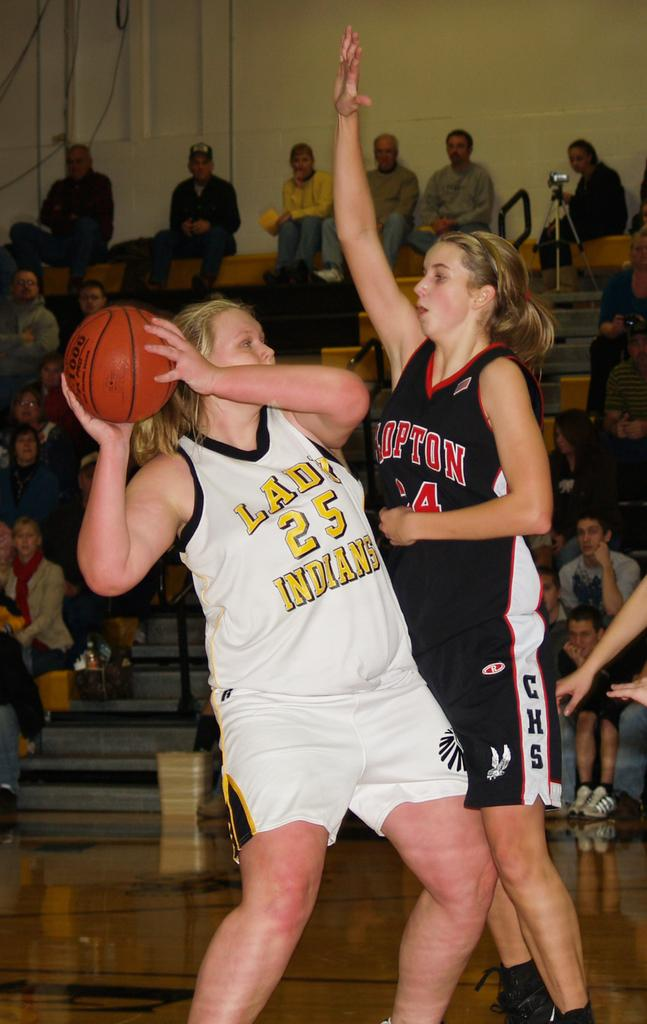<image>
Relay a brief, clear account of the picture shown. Two female basketball players are fighting over the ball and the player with the ball's jersey say Indians. 